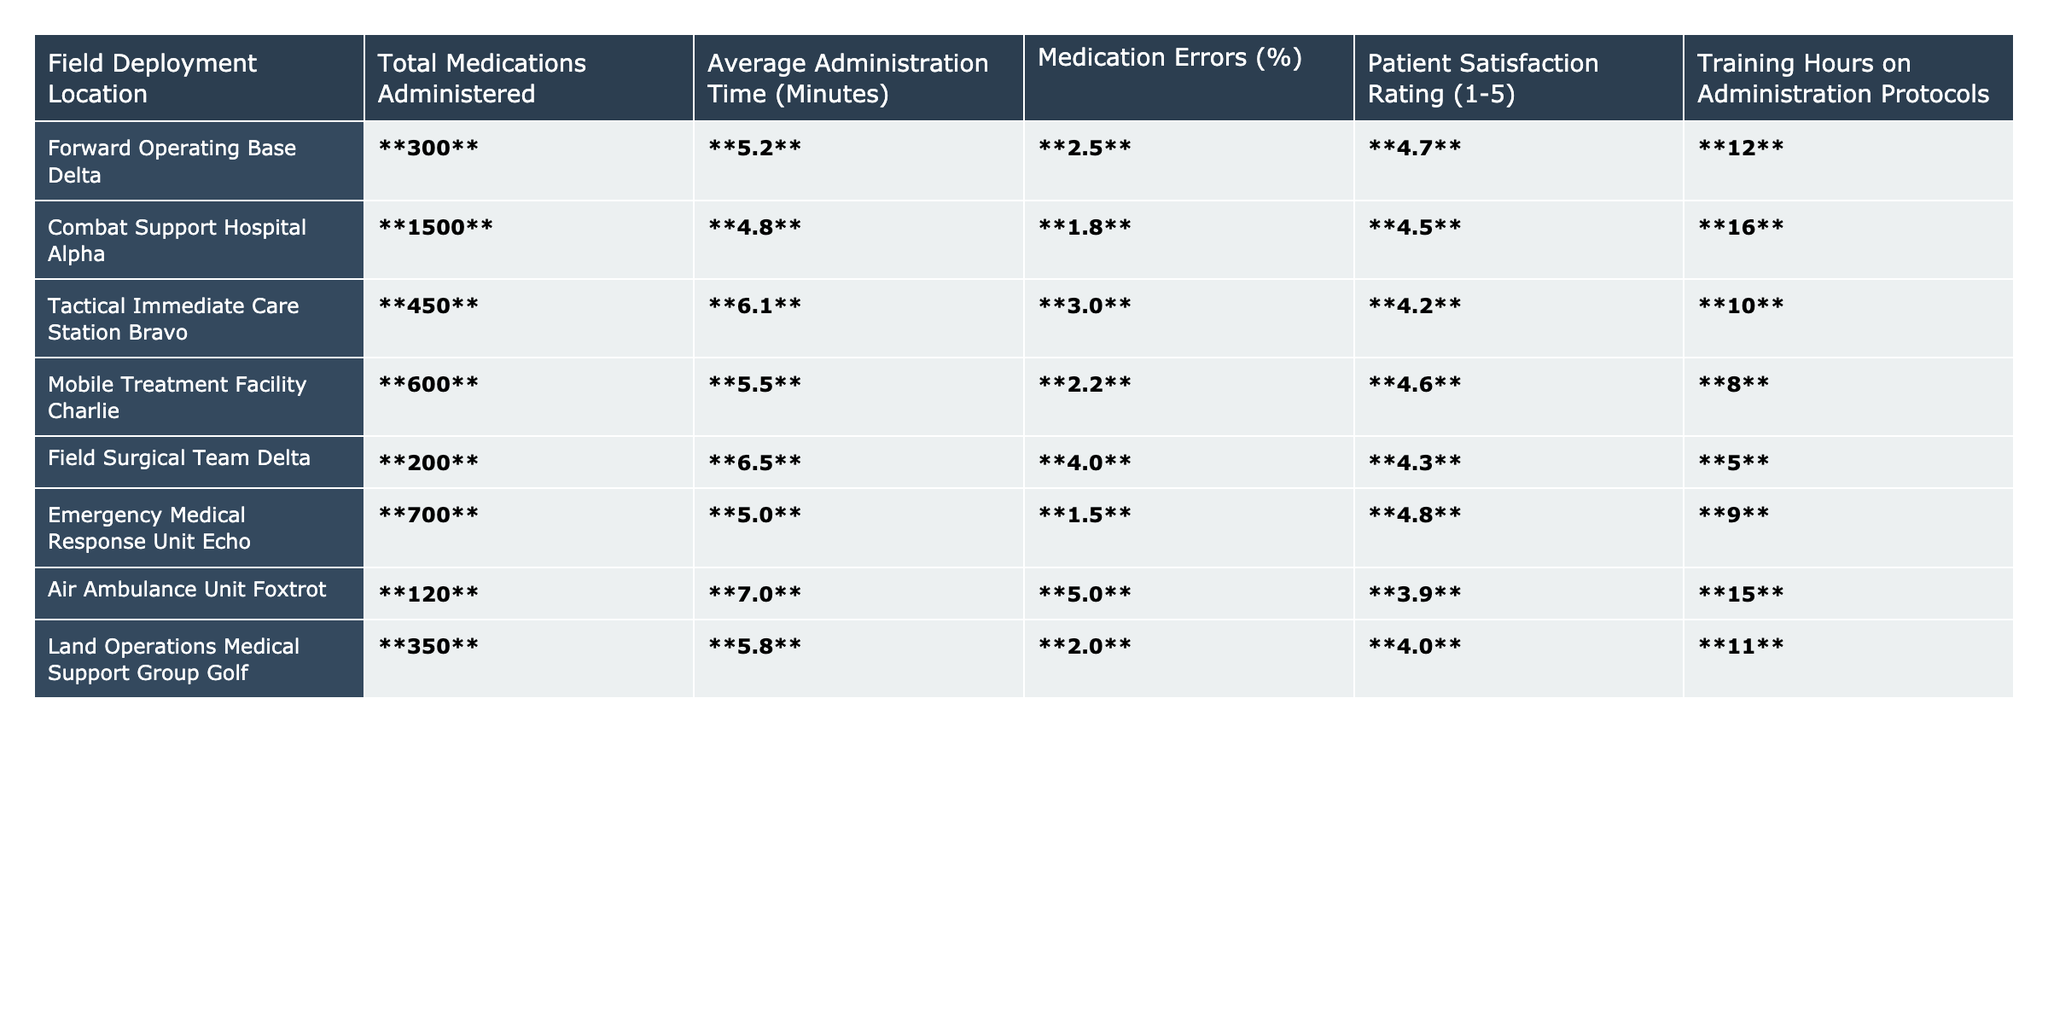What is the total number of medications administered at Combat Support Hospital Alpha? The table shows that Combat Support Hospital Alpha administered **1500** medications.
Answer: 1500 What is the average administration time for medications at Forward Operating Base Delta? According to the table, the average administration time at Forward Operating Base Delta is **5.2** minutes.
Answer: 5.2 minutes Which field deployment location has the highest patient satisfaction rating? The table reveals that the highest patient satisfaction rating is **4.8**, which is at Emergency Medical Response Unit Echo.
Answer: Emergency Medical Response Unit Echo Calculating the average medication errors across all deployment locations, what is the resulting percentage? We sum the medication errors percentages: 2.5 + 1.8 + 3.0 + 2.2 + 4.0 + 1.5 + 5.0 + 2.0 = 22.0, and then divide by the number of locations (8). So the average is 22.0/8 = 2.75%.
Answer: 2.75% What percentage of medication errors occurred at Tactical Immediate Care Station Bravo? Based on the table, Tactical Immediate Care Station Bravo experienced **3.0%** medication errors.
Answer: 3.0% Is the average administration time shorter at Mobile Treatment Facility Charlie compared to Air Ambulance Unit Foxtrot? The average administration time at Mobile Treatment Facility Charlie is **5.5** minutes, which is less than **7.0** minutes at Air Ambulance Unit Foxtrot. Thus, the statement is true.
Answer: Yes Which field deployment had the lowest training hours on administration protocols? The table indicates that Field Surgical Team Delta had the lowest training hours at **5** hours.
Answer: Field Surgical Team Delta What is the difference in average administration time between the fastest and slowest deployment locations? The fastest administration time is at Combat Support Hospital Alpha at **4.8** minutes, and the slowest is Air Ambulance Unit Foxtrot at **7.0** minutes. Thus, the difference is 7.0 - 4.8 = 2.2 minutes.
Answer: 2.2 minutes Which deployment location had a patient satisfaction rating of 4.0 or higher but had a medication error percentage above 2.0%? By inspecting the table, Mobile Treatment Facility Charlie has a satisfaction rating of **4.6** with a medication error percentage of **2.2%**.
Answer: Mobile Treatment Facility Charlie What can be inferred about the correlation between training hours and medication errors from the data presented? Reviewing the table, we see that generally, as training hours increase, the medication errors decrease. However, Tactical Immediate Care Station Bravo, with **10** training hours, has higher errors at **3.0%** compared to Land Operations Medical Support Group Golf. Thus, while some correlation may exist, it is not consistently strong across all cases.
Answer: Generally inverse, but inconsistent 